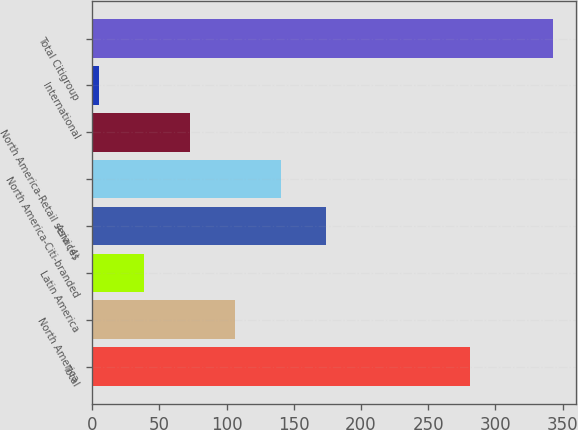Convert chart. <chart><loc_0><loc_0><loc_500><loc_500><bar_chart><fcel>Total<fcel>North America<fcel>Latin America<fcel>Asia (4)<fcel>North America-Citi-branded<fcel>North America-Retail services<fcel>International<fcel>Total Citigroup<nl><fcel>281.3<fcel>106.37<fcel>38.79<fcel>173.95<fcel>140.16<fcel>72.58<fcel>5<fcel>342.9<nl></chart> 